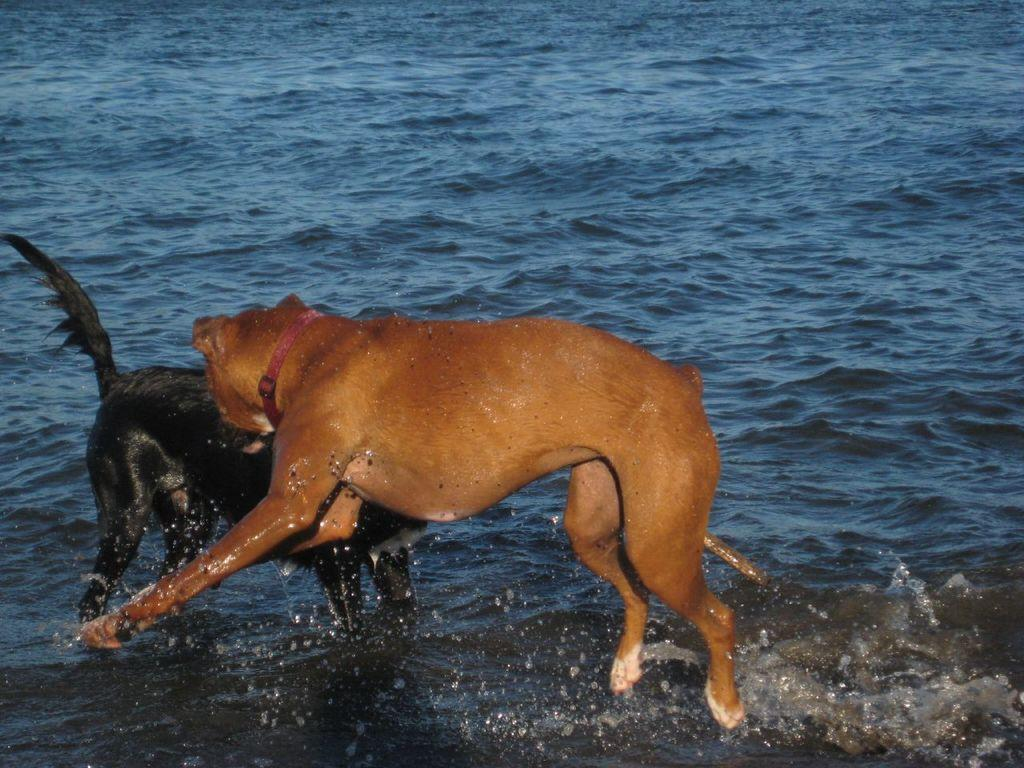How many dogs are present in the image? There are two dogs in the image. Where are the dogs located? The dogs are in the water. What are the dogs doing in the image? The dogs appear to be engaged in a physical altercation (fighting). What type of fog can be seen in the image? There is no fog present in the image; it features two dogs in the water. What kind of arch is visible in the image? There is no arch present in the image; it features two dogs in the water. 